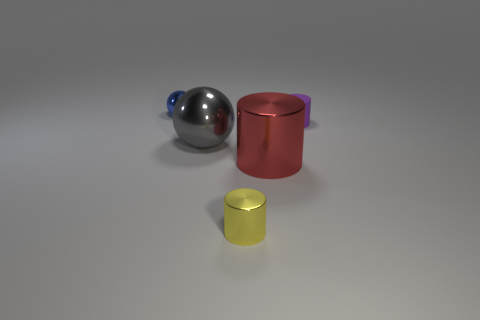How many cylinders are either big red metal things or tiny yellow objects? In the image, we can identify one cylinder, which is the large red object. The tiny yellow object appears to be a small cylinder as well, making the total count 2. To be precise, there are two cylindrical objects: one is large and red, and the other is small and yellow. 